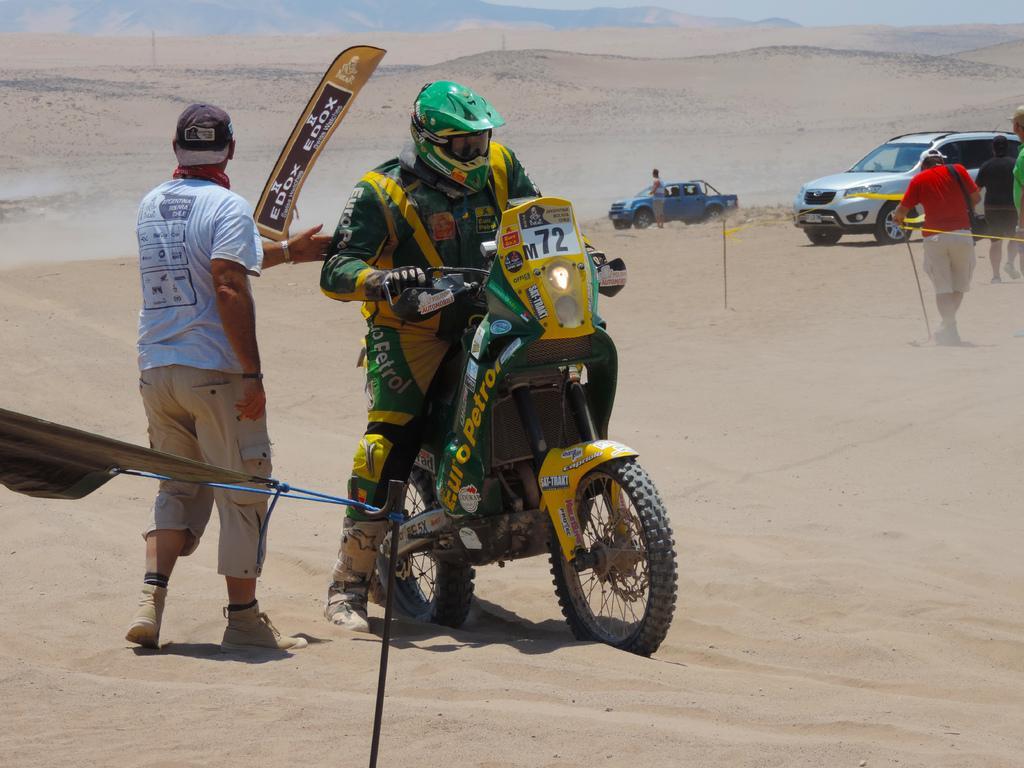Describe this image in one or two sentences. On the background we can see hills. This is a desert. We can see vehicles and persons standing and walking and this man is sitting on a bike. 